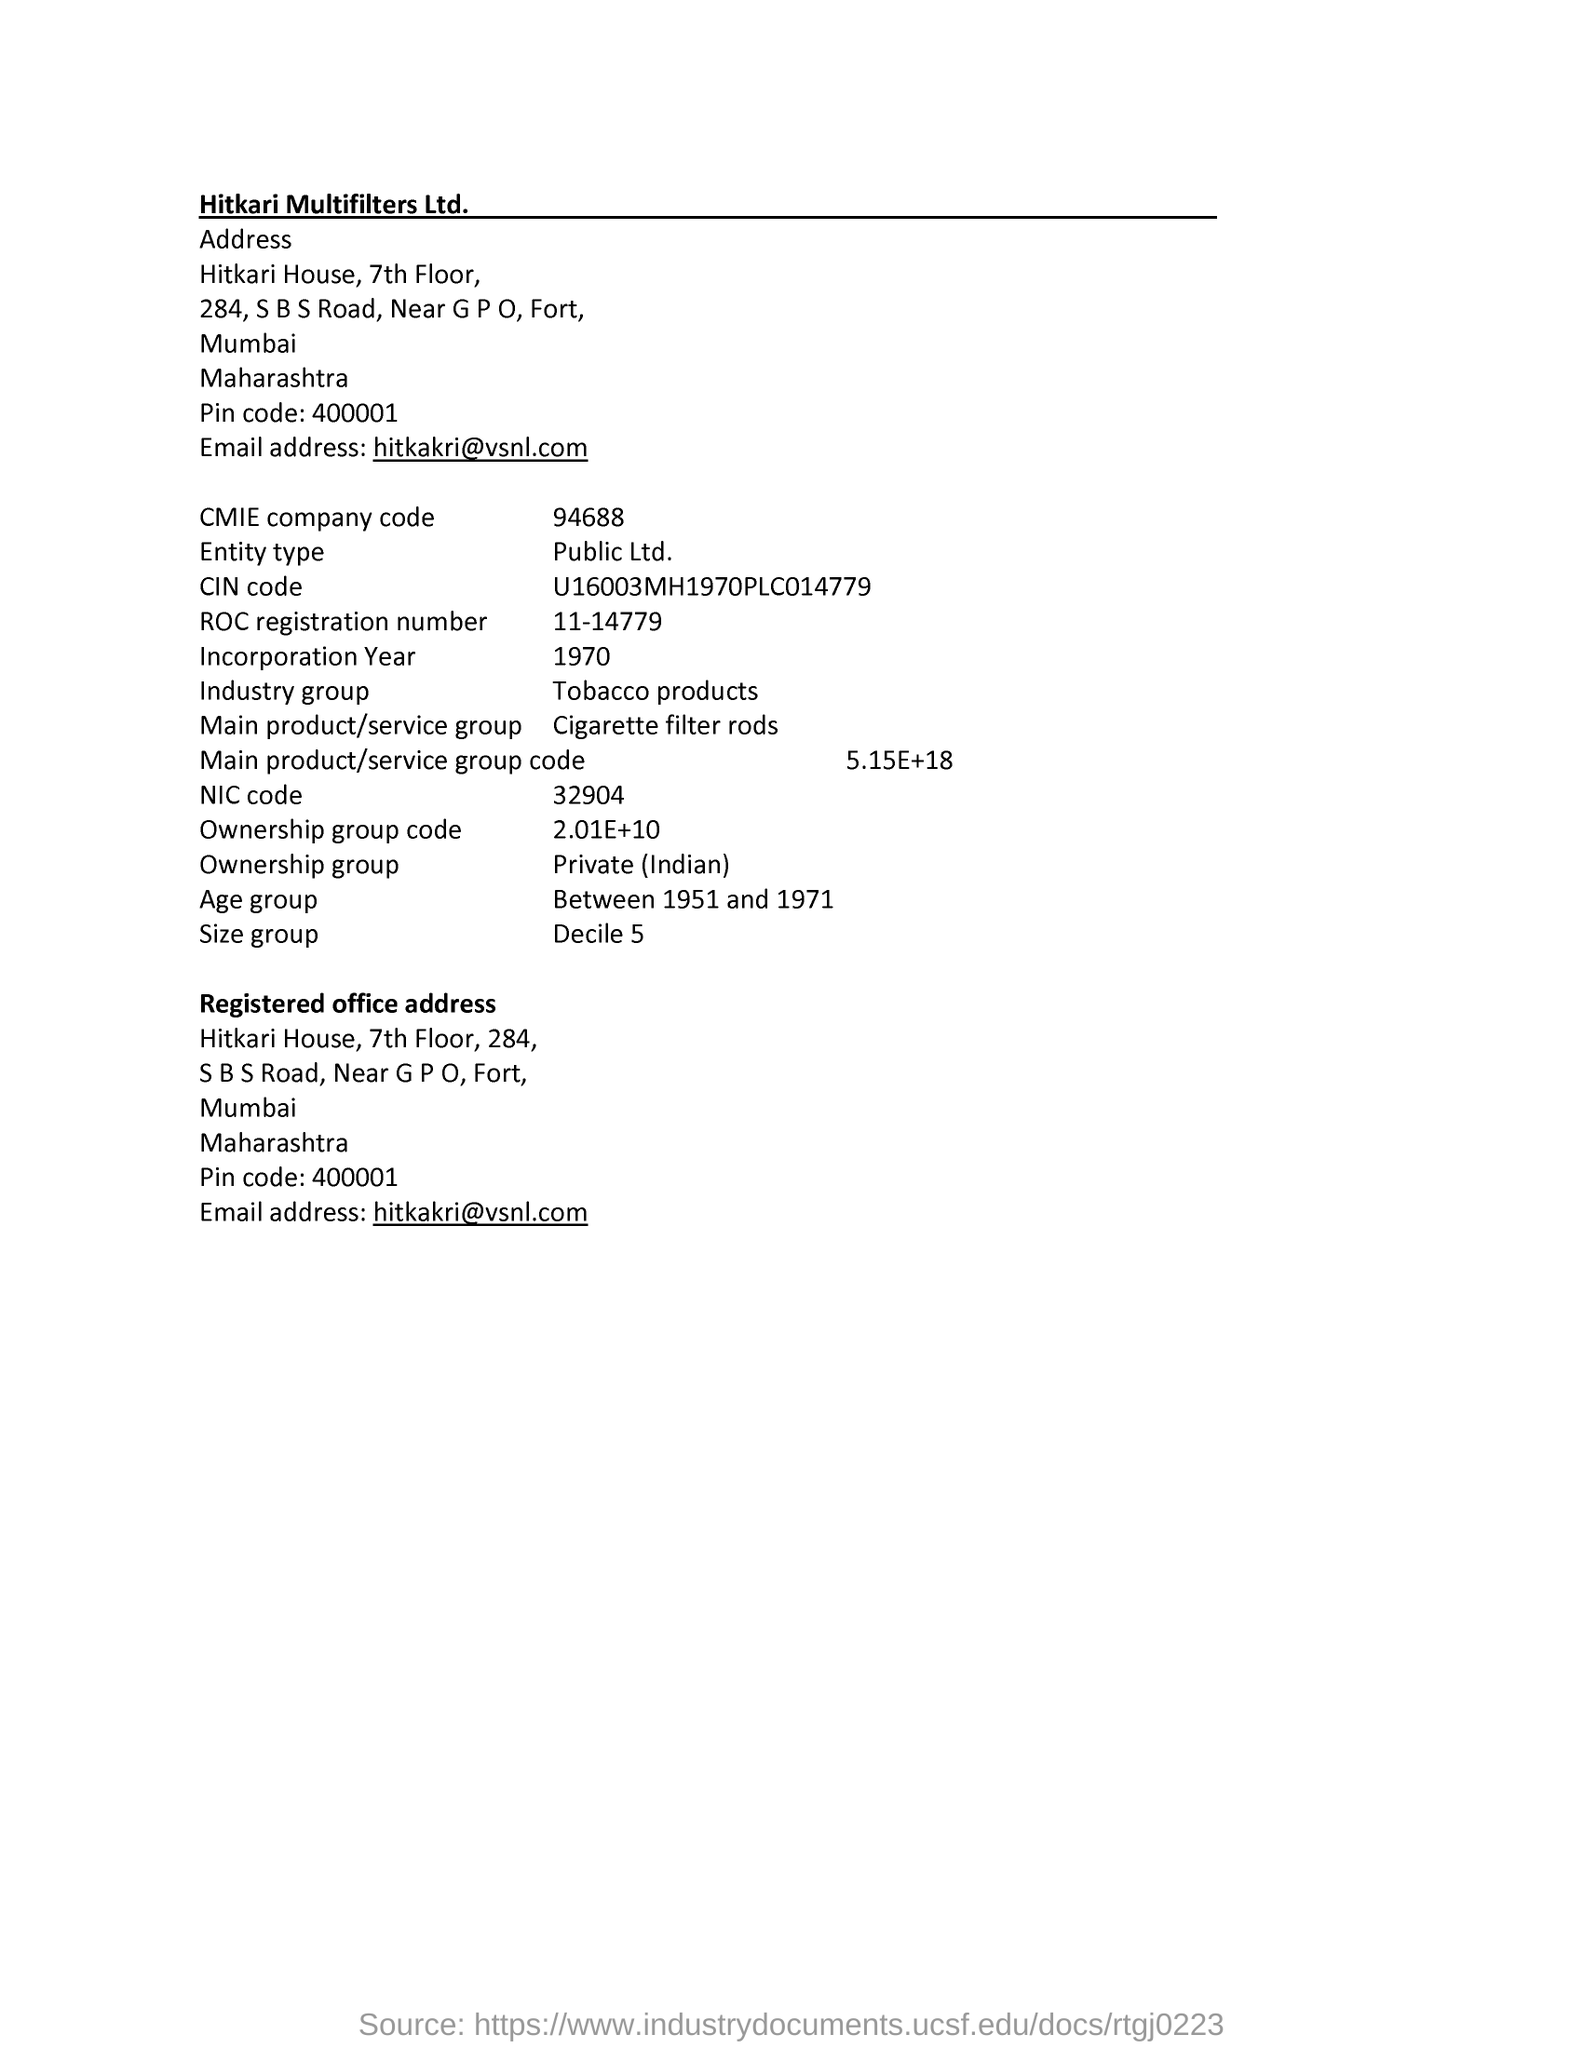What is the age group mentioned in the page?
Ensure brevity in your answer.  Between 1951 and 1971. What is NIC code?
Make the answer very short. 32904. What is CMIE company code?
Keep it short and to the point. 94688. Find email id of the company?
Your answer should be compact. Hitkakri@vsnl.com. What is the company's name?
Make the answer very short. Hitkari Multifilters Ltd. 